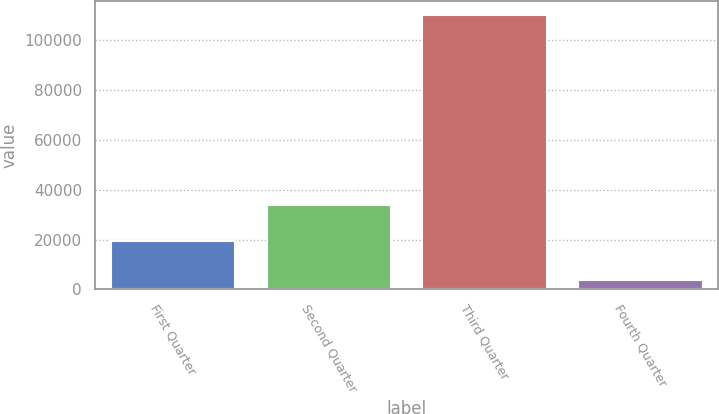<chart> <loc_0><loc_0><loc_500><loc_500><bar_chart><fcel>First Quarter<fcel>Second Quarter<fcel>Third Quarter<fcel>Fourth Quarter<nl><fcel>19294<fcel>33891<fcel>110148<fcel>3879<nl></chart> 